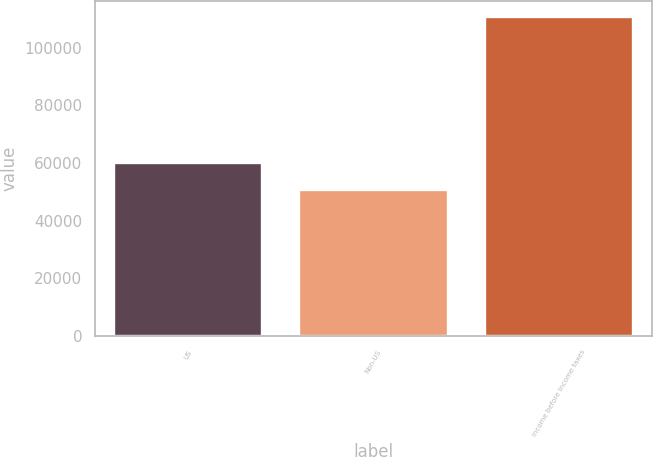Convert chart. <chart><loc_0><loc_0><loc_500><loc_500><bar_chart><fcel>US<fcel>Non-US<fcel>Income before income taxes<nl><fcel>59884<fcel>50613<fcel>110497<nl></chart> 